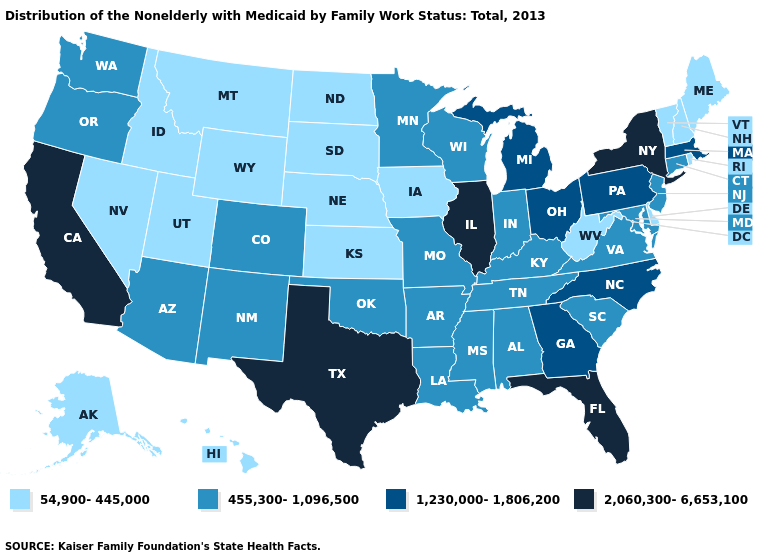What is the highest value in the Northeast ?
Quick response, please. 2,060,300-6,653,100. Among the states that border West Virginia , does Ohio have the lowest value?
Keep it brief. No. What is the value of Colorado?
Give a very brief answer. 455,300-1,096,500. Name the states that have a value in the range 1,230,000-1,806,200?
Be succinct. Georgia, Massachusetts, Michigan, North Carolina, Ohio, Pennsylvania. What is the highest value in the USA?
Answer briefly. 2,060,300-6,653,100. What is the highest value in the West ?
Give a very brief answer. 2,060,300-6,653,100. Which states have the lowest value in the USA?
Concise answer only. Alaska, Delaware, Hawaii, Idaho, Iowa, Kansas, Maine, Montana, Nebraska, Nevada, New Hampshire, North Dakota, Rhode Island, South Dakota, Utah, Vermont, West Virginia, Wyoming. Does Delaware have the same value as Oklahoma?
Quick response, please. No. How many symbols are there in the legend?
Keep it brief. 4. What is the value of Minnesota?
Write a very short answer. 455,300-1,096,500. Among the states that border Tennessee , which have the lowest value?
Answer briefly. Alabama, Arkansas, Kentucky, Mississippi, Missouri, Virginia. Name the states that have a value in the range 54,900-445,000?
Answer briefly. Alaska, Delaware, Hawaii, Idaho, Iowa, Kansas, Maine, Montana, Nebraska, Nevada, New Hampshire, North Dakota, Rhode Island, South Dakota, Utah, Vermont, West Virginia, Wyoming. Name the states that have a value in the range 54,900-445,000?
Be succinct. Alaska, Delaware, Hawaii, Idaho, Iowa, Kansas, Maine, Montana, Nebraska, Nevada, New Hampshire, North Dakota, Rhode Island, South Dakota, Utah, Vermont, West Virginia, Wyoming. Does Oregon have the lowest value in the West?
Keep it brief. No. 